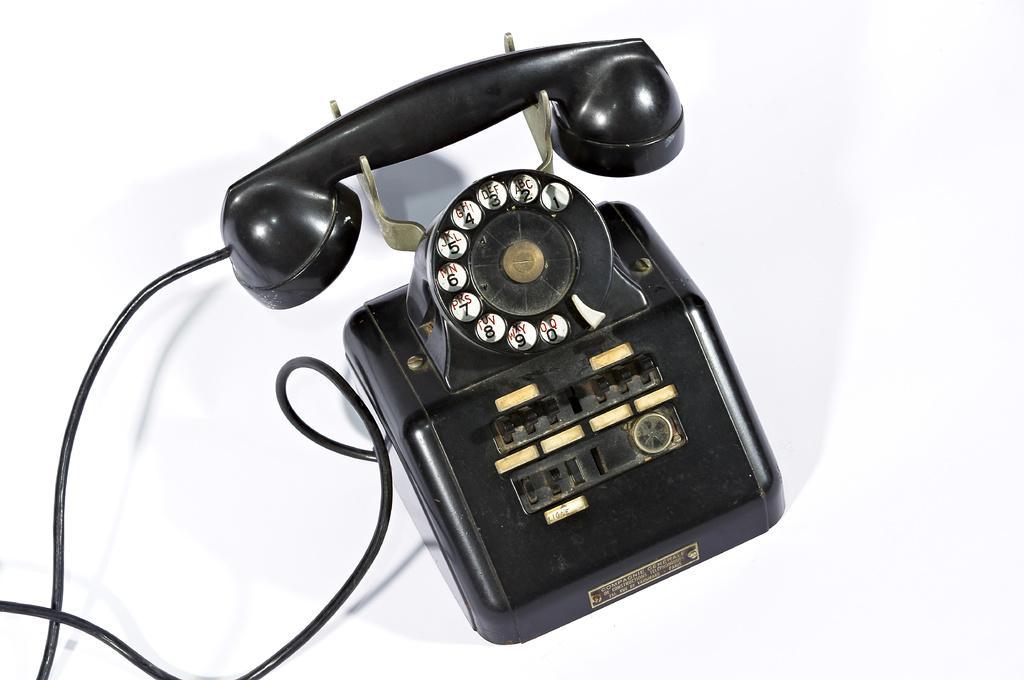Describe this image in one or two sentences. In this picture we can see a black telephone and a cable on a white object. 